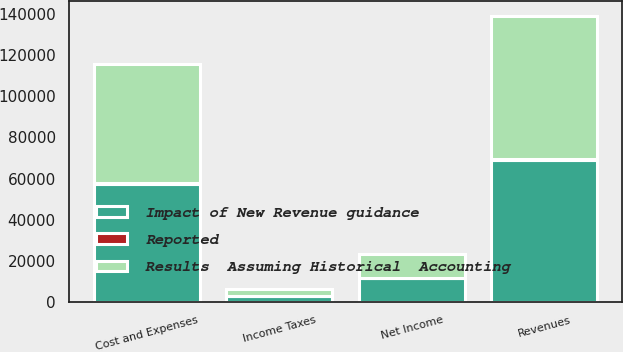Convert chart. <chart><loc_0><loc_0><loc_500><loc_500><stacked_bar_chart><ecel><fcel>Revenues<fcel>Cost and Expenses<fcel>Income Taxes<fcel>Net Income<nl><fcel>Impact of New Revenue guidance<fcel>69225<fcel>57465<fcel>3010<fcel>11514<nl><fcel>Reported<fcel>345<fcel>254<fcel>21<fcel>70<nl><fcel>Results  Assuming Historical  Accounting<fcel>69570<fcel>57719<fcel>3031<fcel>11584<nl></chart> 